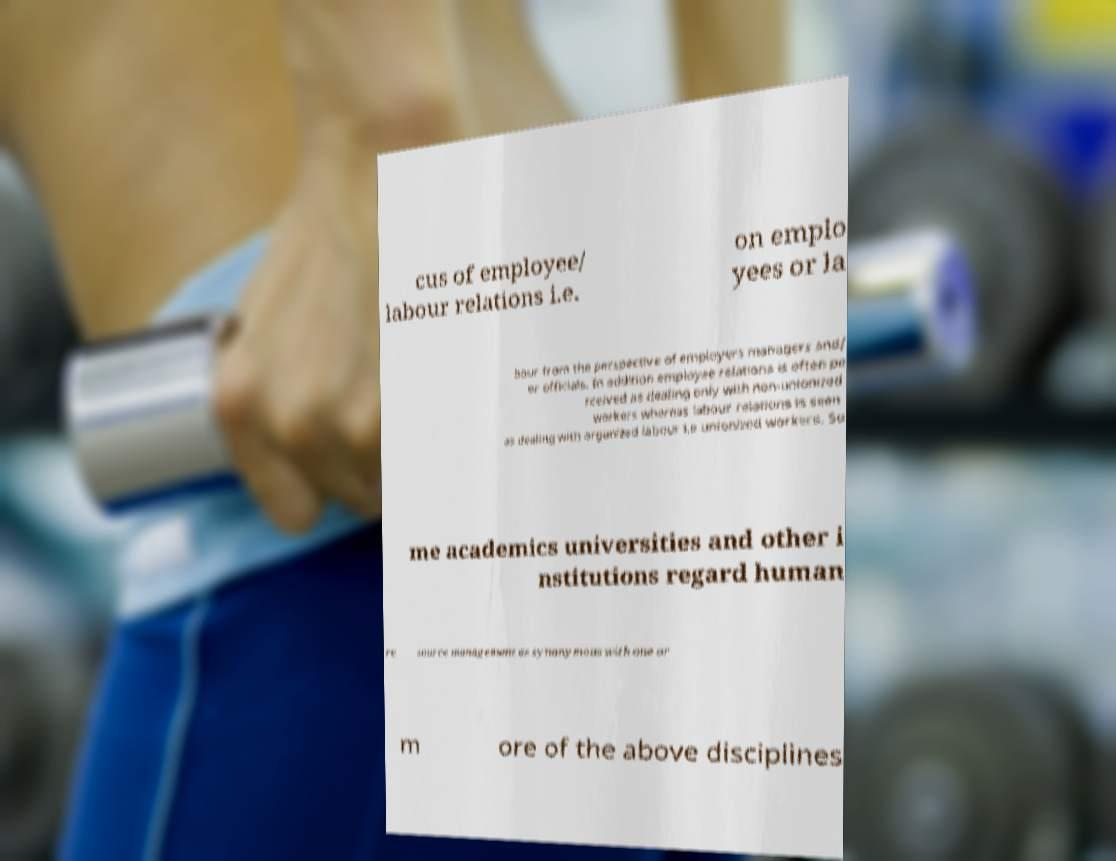I need the written content from this picture converted into text. Can you do that? cus of employee/ labour relations i.e. on emplo yees or la bour from the perspective of employers managers and/ or officials. In addition employee relations is often pe rceived as dealing only with non-unionized workers whereas labour relations is seen as dealing with organized labour i.e unionized workers. So me academics universities and other i nstitutions regard human re source management as synonymous with one or m ore of the above disciplines 